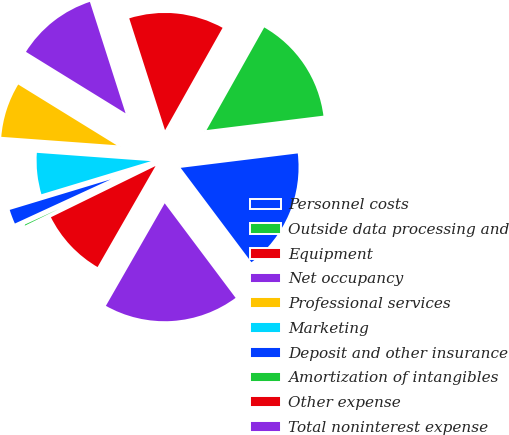Convert chart to OTSL. <chart><loc_0><loc_0><loc_500><loc_500><pie_chart><fcel>Personnel costs<fcel>Outside data processing and<fcel>Equipment<fcel>Net occupancy<fcel>Professional services<fcel>Marketing<fcel>Deposit and other insurance<fcel>Amortization of intangibles<fcel>Other expense<fcel>Total noninterest expense<nl><fcel>16.71%<fcel>14.9%<fcel>13.08%<fcel>11.27%<fcel>7.64%<fcel>5.83%<fcel>2.2%<fcel>0.38%<fcel>9.46%<fcel>18.53%<nl></chart> 